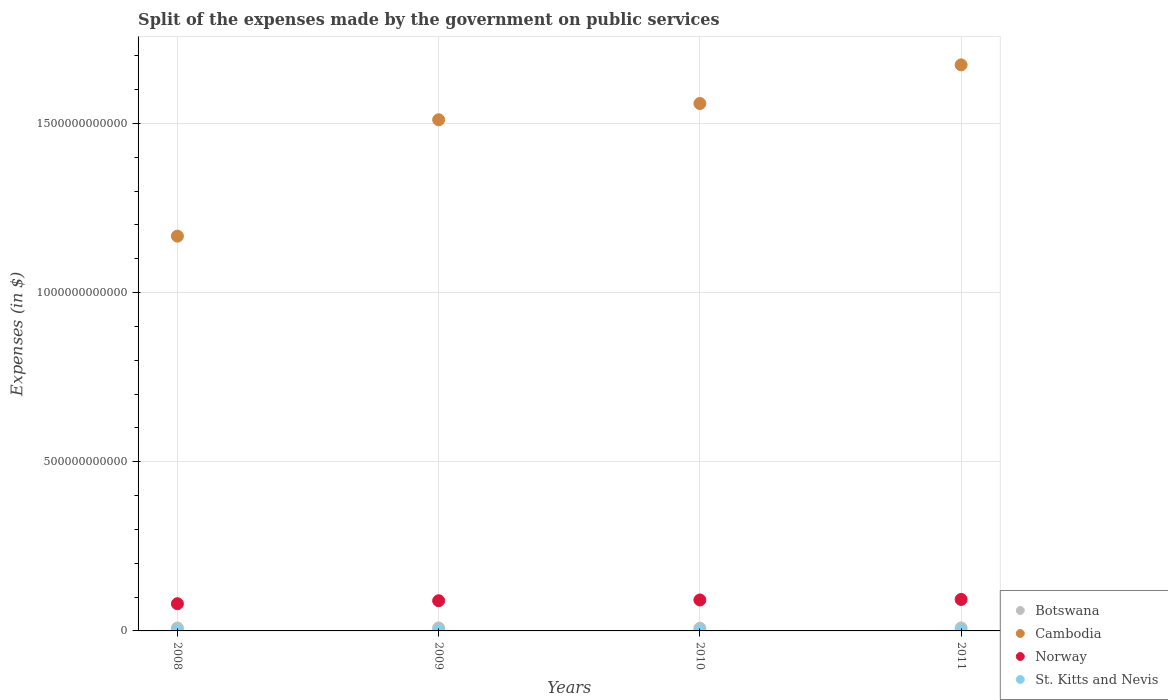How many different coloured dotlines are there?
Give a very brief answer. 4. What is the expenses made by the government on public services in St. Kitts and Nevis in 2009?
Keep it short and to the point. 1.29e+08. Across all years, what is the maximum expenses made by the government on public services in St. Kitts and Nevis?
Keep it short and to the point. 1.76e+08. Across all years, what is the minimum expenses made by the government on public services in Cambodia?
Your answer should be very brief. 1.17e+12. In which year was the expenses made by the government on public services in Botswana minimum?
Your response must be concise. 2010. What is the total expenses made by the government on public services in Cambodia in the graph?
Offer a terse response. 5.91e+12. What is the difference between the expenses made by the government on public services in St. Kitts and Nevis in 2009 and that in 2011?
Offer a very short reply. -4.70e+07. What is the difference between the expenses made by the government on public services in Botswana in 2010 and the expenses made by the government on public services in Cambodia in 2009?
Offer a very short reply. -1.50e+12. What is the average expenses made by the government on public services in Botswana per year?
Keep it short and to the point. 8.56e+09. In the year 2008, what is the difference between the expenses made by the government on public services in Botswana and expenses made by the government on public services in Cambodia?
Your answer should be very brief. -1.16e+12. In how many years, is the expenses made by the government on public services in Botswana greater than 500000000000 $?
Give a very brief answer. 0. What is the ratio of the expenses made by the government on public services in Cambodia in 2010 to that in 2011?
Make the answer very short. 0.93. What is the difference between the highest and the second highest expenses made by the government on public services in Cambodia?
Your response must be concise. 1.14e+11. What is the difference between the highest and the lowest expenses made by the government on public services in Cambodia?
Keep it short and to the point. 5.06e+11. Is the sum of the expenses made by the government on public services in Norway in 2010 and 2011 greater than the maximum expenses made by the government on public services in St. Kitts and Nevis across all years?
Provide a short and direct response. Yes. Is it the case that in every year, the sum of the expenses made by the government on public services in Botswana and expenses made by the government on public services in St. Kitts and Nevis  is greater than the sum of expenses made by the government on public services in Cambodia and expenses made by the government on public services in Norway?
Keep it short and to the point. No. Is it the case that in every year, the sum of the expenses made by the government on public services in Norway and expenses made by the government on public services in St. Kitts and Nevis  is greater than the expenses made by the government on public services in Botswana?
Offer a very short reply. Yes. Is the expenses made by the government on public services in Botswana strictly greater than the expenses made by the government on public services in Norway over the years?
Offer a terse response. No. Is the expenses made by the government on public services in Botswana strictly less than the expenses made by the government on public services in Cambodia over the years?
Keep it short and to the point. Yes. How many dotlines are there?
Offer a very short reply. 4. What is the difference between two consecutive major ticks on the Y-axis?
Offer a terse response. 5.00e+11. How are the legend labels stacked?
Your answer should be very brief. Vertical. What is the title of the graph?
Give a very brief answer. Split of the expenses made by the government on public services. What is the label or title of the X-axis?
Offer a very short reply. Years. What is the label or title of the Y-axis?
Offer a very short reply. Expenses (in $). What is the Expenses (in $) in Botswana in 2008?
Keep it short and to the point. 8.64e+09. What is the Expenses (in $) in Cambodia in 2008?
Ensure brevity in your answer.  1.17e+12. What is the Expenses (in $) in Norway in 2008?
Offer a very short reply. 8.04e+1. What is the Expenses (in $) of St. Kitts and Nevis in 2008?
Your answer should be very brief. 1.37e+08. What is the Expenses (in $) of Botswana in 2009?
Keep it short and to the point. 8.80e+09. What is the Expenses (in $) of Cambodia in 2009?
Your answer should be very brief. 1.51e+12. What is the Expenses (in $) of Norway in 2009?
Make the answer very short. 8.92e+1. What is the Expenses (in $) in St. Kitts and Nevis in 2009?
Your answer should be compact. 1.29e+08. What is the Expenses (in $) in Botswana in 2010?
Your answer should be compact. 7.94e+09. What is the Expenses (in $) of Cambodia in 2010?
Offer a terse response. 1.56e+12. What is the Expenses (in $) in Norway in 2010?
Ensure brevity in your answer.  9.15e+1. What is the Expenses (in $) of St. Kitts and Nevis in 2010?
Offer a terse response. 1.18e+08. What is the Expenses (in $) of Botswana in 2011?
Offer a terse response. 8.84e+09. What is the Expenses (in $) in Cambodia in 2011?
Give a very brief answer. 1.67e+12. What is the Expenses (in $) in Norway in 2011?
Your response must be concise. 9.30e+1. What is the Expenses (in $) in St. Kitts and Nevis in 2011?
Provide a short and direct response. 1.76e+08. Across all years, what is the maximum Expenses (in $) in Botswana?
Provide a short and direct response. 8.84e+09. Across all years, what is the maximum Expenses (in $) of Cambodia?
Make the answer very short. 1.67e+12. Across all years, what is the maximum Expenses (in $) of Norway?
Keep it short and to the point. 9.30e+1. Across all years, what is the maximum Expenses (in $) of St. Kitts and Nevis?
Your response must be concise. 1.76e+08. Across all years, what is the minimum Expenses (in $) of Botswana?
Your answer should be very brief. 7.94e+09. Across all years, what is the minimum Expenses (in $) in Cambodia?
Provide a short and direct response. 1.17e+12. Across all years, what is the minimum Expenses (in $) in Norway?
Your answer should be very brief. 8.04e+1. Across all years, what is the minimum Expenses (in $) of St. Kitts and Nevis?
Give a very brief answer. 1.18e+08. What is the total Expenses (in $) of Botswana in the graph?
Keep it short and to the point. 3.42e+1. What is the total Expenses (in $) of Cambodia in the graph?
Your answer should be compact. 5.91e+12. What is the total Expenses (in $) of Norway in the graph?
Your answer should be compact. 3.54e+11. What is the total Expenses (in $) of St. Kitts and Nevis in the graph?
Keep it short and to the point. 5.60e+08. What is the difference between the Expenses (in $) of Botswana in 2008 and that in 2009?
Provide a short and direct response. -1.62e+08. What is the difference between the Expenses (in $) of Cambodia in 2008 and that in 2009?
Offer a terse response. -3.44e+11. What is the difference between the Expenses (in $) in Norway in 2008 and that in 2009?
Your answer should be very brief. -8.85e+09. What is the difference between the Expenses (in $) of St. Kitts and Nevis in 2008 and that in 2009?
Offer a terse response. 8.10e+06. What is the difference between the Expenses (in $) in Botswana in 2008 and that in 2010?
Your answer should be very brief. 6.99e+08. What is the difference between the Expenses (in $) in Cambodia in 2008 and that in 2010?
Keep it short and to the point. -3.92e+11. What is the difference between the Expenses (in $) of Norway in 2008 and that in 2010?
Offer a very short reply. -1.11e+1. What is the difference between the Expenses (in $) of St. Kitts and Nevis in 2008 and that in 2010?
Your answer should be very brief. 1.91e+07. What is the difference between the Expenses (in $) of Botswana in 2008 and that in 2011?
Give a very brief answer. -2.00e+08. What is the difference between the Expenses (in $) in Cambodia in 2008 and that in 2011?
Make the answer very short. -5.06e+11. What is the difference between the Expenses (in $) in Norway in 2008 and that in 2011?
Offer a terse response. -1.26e+1. What is the difference between the Expenses (in $) in St. Kitts and Nevis in 2008 and that in 2011?
Make the answer very short. -3.89e+07. What is the difference between the Expenses (in $) in Botswana in 2009 and that in 2010?
Make the answer very short. 8.61e+08. What is the difference between the Expenses (in $) of Cambodia in 2009 and that in 2010?
Offer a terse response. -4.80e+1. What is the difference between the Expenses (in $) in Norway in 2009 and that in 2010?
Keep it short and to the point. -2.29e+09. What is the difference between the Expenses (in $) of St. Kitts and Nevis in 2009 and that in 2010?
Offer a very short reply. 1.10e+07. What is the difference between the Expenses (in $) in Botswana in 2009 and that in 2011?
Your response must be concise. -3.82e+07. What is the difference between the Expenses (in $) in Cambodia in 2009 and that in 2011?
Your response must be concise. -1.62e+11. What is the difference between the Expenses (in $) in Norway in 2009 and that in 2011?
Offer a very short reply. -3.76e+09. What is the difference between the Expenses (in $) in St. Kitts and Nevis in 2009 and that in 2011?
Make the answer very short. -4.70e+07. What is the difference between the Expenses (in $) of Botswana in 2010 and that in 2011?
Give a very brief answer. -8.99e+08. What is the difference between the Expenses (in $) in Cambodia in 2010 and that in 2011?
Your answer should be compact. -1.14e+11. What is the difference between the Expenses (in $) of Norway in 2010 and that in 2011?
Offer a terse response. -1.47e+09. What is the difference between the Expenses (in $) of St. Kitts and Nevis in 2010 and that in 2011?
Ensure brevity in your answer.  -5.80e+07. What is the difference between the Expenses (in $) in Botswana in 2008 and the Expenses (in $) in Cambodia in 2009?
Keep it short and to the point. -1.50e+12. What is the difference between the Expenses (in $) of Botswana in 2008 and the Expenses (in $) of Norway in 2009?
Make the answer very short. -8.06e+1. What is the difference between the Expenses (in $) in Botswana in 2008 and the Expenses (in $) in St. Kitts and Nevis in 2009?
Offer a very short reply. 8.51e+09. What is the difference between the Expenses (in $) in Cambodia in 2008 and the Expenses (in $) in Norway in 2009?
Make the answer very short. 1.08e+12. What is the difference between the Expenses (in $) of Cambodia in 2008 and the Expenses (in $) of St. Kitts and Nevis in 2009?
Give a very brief answer. 1.17e+12. What is the difference between the Expenses (in $) in Norway in 2008 and the Expenses (in $) in St. Kitts and Nevis in 2009?
Your response must be concise. 8.03e+1. What is the difference between the Expenses (in $) of Botswana in 2008 and the Expenses (in $) of Cambodia in 2010?
Ensure brevity in your answer.  -1.55e+12. What is the difference between the Expenses (in $) of Botswana in 2008 and the Expenses (in $) of Norway in 2010?
Ensure brevity in your answer.  -8.29e+1. What is the difference between the Expenses (in $) in Botswana in 2008 and the Expenses (in $) in St. Kitts and Nevis in 2010?
Provide a succinct answer. 8.52e+09. What is the difference between the Expenses (in $) of Cambodia in 2008 and the Expenses (in $) of Norway in 2010?
Offer a terse response. 1.08e+12. What is the difference between the Expenses (in $) in Cambodia in 2008 and the Expenses (in $) in St. Kitts and Nevis in 2010?
Provide a short and direct response. 1.17e+12. What is the difference between the Expenses (in $) in Norway in 2008 and the Expenses (in $) in St. Kitts and Nevis in 2010?
Your answer should be compact. 8.03e+1. What is the difference between the Expenses (in $) in Botswana in 2008 and the Expenses (in $) in Cambodia in 2011?
Provide a short and direct response. -1.66e+12. What is the difference between the Expenses (in $) of Botswana in 2008 and the Expenses (in $) of Norway in 2011?
Provide a short and direct response. -8.44e+1. What is the difference between the Expenses (in $) in Botswana in 2008 and the Expenses (in $) in St. Kitts and Nevis in 2011?
Give a very brief answer. 8.46e+09. What is the difference between the Expenses (in $) of Cambodia in 2008 and the Expenses (in $) of Norway in 2011?
Offer a very short reply. 1.07e+12. What is the difference between the Expenses (in $) of Cambodia in 2008 and the Expenses (in $) of St. Kitts and Nevis in 2011?
Make the answer very short. 1.17e+12. What is the difference between the Expenses (in $) of Norway in 2008 and the Expenses (in $) of St. Kitts and Nevis in 2011?
Keep it short and to the point. 8.02e+1. What is the difference between the Expenses (in $) in Botswana in 2009 and the Expenses (in $) in Cambodia in 2010?
Your answer should be compact. -1.55e+12. What is the difference between the Expenses (in $) in Botswana in 2009 and the Expenses (in $) in Norway in 2010?
Make the answer very short. -8.27e+1. What is the difference between the Expenses (in $) of Botswana in 2009 and the Expenses (in $) of St. Kitts and Nevis in 2010?
Your response must be concise. 8.68e+09. What is the difference between the Expenses (in $) in Cambodia in 2009 and the Expenses (in $) in Norway in 2010?
Provide a succinct answer. 1.42e+12. What is the difference between the Expenses (in $) of Cambodia in 2009 and the Expenses (in $) of St. Kitts and Nevis in 2010?
Offer a very short reply. 1.51e+12. What is the difference between the Expenses (in $) of Norway in 2009 and the Expenses (in $) of St. Kitts and Nevis in 2010?
Offer a terse response. 8.91e+1. What is the difference between the Expenses (in $) of Botswana in 2009 and the Expenses (in $) of Cambodia in 2011?
Offer a terse response. -1.66e+12. What is the difference between the Expenses (in $) in Botswana in 2009 and the Expenses (in $) in Norway in 2011?
Make the answer very short. -8.42e+1. What is the difference between the Expenses (in $) of Botswana in 2009 and the Expenses (in $) of St. Kitts and Nevis in 2011?
Your answer should be compact. 8.63e+09. What is the difference between the Expenses (in $) in Cambodia in 2009 and the Expenses (in $) in Norway in 2011?
Make the answer very short. 1.42e+12. What is the difference between the Expenses (in $) in Cambodia in 2009 and the Expenses (in $) in St. Kitts and Nevis in 2011?
Make the answer very short. 1.51e+12. What is the difference between the Expenses (in $) in Norway in 2009 and the Expenses (in $) in St. Kitts and Nevis in 2011?
Ensure brevity in your answer.  8.91e+1. What is the difference between the Expenses (in $) of Botswana in 2010 and the Expenses (in $) of Cambodia in 2011?
Offer a very short reply. -1.67e+12. What is the difference between the Expenses (in $) in Botswana in 2010 and the Expenses (in $) in Norway in 2011?
Your answer should be very brief. -8.50e+1. What is the difference between the Expenses (in $) of Botswana in 2010 and the Expenses (in $) of St. Kitts and Nevis in 2011?
Give a very brief answer. 7.76e+09. What is the difference between the Expenses (in $) in Cambodia in 2010 and the Expenses (in $) in Norway in 2011?
Keep it short and to the point. 1.47e+12. What is the difference between the Expenses (in $) of Cambodia in 2010 and the Expenses (in $) of St. Kitts and Nevis in 2011?
Offer a terse response. 1.56e+12. What is the difference between the Expenses (in $) in Norway in 2010 and the Expenses (in $) in St. Kitts and Nevis in 2011?
Provide a succinct answer. 9.13e+1. What is the average Expenses (in $) of Botswana per year?
Provide a succinct answer. 8.56e+09. What is the average Expenses (in $) in Cambodia per year?
Provide a short and direct response. 1.48e+12. What is the average Expenses (in $) in Norway per year?
Make the answer very short. 8.85e+1. What is the average Expenses (in $) in St. Kitts and Nevis per year?
Your response must be concise. 1.40e+08. In the year 2008, what is the difference between the Expenses (in $) of Botswana and Expenses (in $) of Cambodia?
Your response must be concise. -1.16e+12. In the year 2008, what is the difference between the Expenses (in $) in Botswana and Expenses (in $) in Norway?
Your answer should be compact. -7.17e+1. In the year 2008, what is the difference between the Expenses (in $) in Botswana and Expenses (in $) in St. Kitts and Nevis?
Give a very brief answer. 8.50e+09. In the year 2008, what is the difference between the Expenses (in $) in Cambodia and Expenses (in $) in Norway?
Your answer should be compact. 1.09e+12. In the year 2008, what is the difference between the Expenses (in $) in Cambodia and Expenses (in $) in St. Kitts and Nevis?
Provide a succinct answer. 1.17e+12. In the year 2008, what is the difference between the Expenses (in $) of Norway and Expenses (in $) of St. Kitts and Nevis?
Make the answer very short. 8.02e+1. In the year 2009, what is the difference between the Expenses (in $) in Botswana and Expenses (in $) in Cambodia?
Your answer should be compact. -1.50e+12. In the year 2009, what is the difference between the Expenses (in $) of Botswana and Expenses (in $) of Norway?
Ensure brevity in your answer.  -8.04e+1. In the year 2009, what is the difference between the Expenses (in $) of Botswana and Expenses (in $) of St. Kitts and Nevis?
Offer a very short reply. 8.67e+09. In the year 2009, what is the difference between the Expenses (in $) in Cambodia and Expenses (in $) in Norway?
Your response must be concise. 1.42e+12. In the year 2009, what is the difference between the Expenses (in $) of Cambodia and Expenses (in $) of St. Kitts and Nevis?
Your answer should be very brief. 1.51e+12. In the year 2009, what is the difference between the Expenses (in $) in Norway and Expenses (in $) in St. Kitts and Nevis?
Your answer should be compact. 8.91e+1. In the year 2010, what is the difference between the Expenses (in $) of Botswana and Expenses (in $) of Cambodia?
Offer a terse response. -1.55e+12. In the year 2010, what is the difference between the Expenses (in $) of Botswana and Expenses (in $) of Norway?
Ensure brevity in your answer.  -8.36e+1. In the year 2010, what is the difference between the Expenses (in $) of Botswana and Expenses (in $) of St. Kitts and Nevis?
Ensure brevity in your answer.  7.82e+09. In the year 2010, what is the difference between the Expenses (in $) in Cambodia and Expenses (in $) in Norway?
Your answer should be compact. 1.47e+12. In the year 2010, what is the difference between the Expenses (in $) of Cambodia and Expenses (in $) of St. Kitts and Nevis?
Offer a terse response. 1.56e+12. In the year 2010, what is the difference between the Expenses (in $) in Norway and Expenses (in $) in St. Kitts and Nevis?
Make the answer very short. 9.14e+1. In the year 2011, what is the difference between the Expenses (in $) in Botswana and Expenses (in $) in Cambodia?
Your answer should be very brief. -1.66e+12. In the year 2011, what is the difference between the Expenses (in $) of Botswana and Expenses (in $) of Norway?
Your response must be concise. -8.41e+1. In the year 2011, what is the difference between the Expenses (in $) in Botswana and Expenses (in $) in St. Kitts and Nevis?
Your answer should be very brief. 8.66e+09. In the year 2011, what is the difference between the Expenses (in $) in Cambodia and Expenses (in $) in Norway?
Offer a terse response. 1.58e+12. In the year 2011, what is the difference between the Expenses (in $) in Cambodia and Expenses (in $) in St. Kitts and Nevis?
Give a very brief answer. 1.67e+12. In the year 2011, what is the difference between the Expenses (in $) of Norway and Expenses (in $) of St. Kitts and Nevis?
Offer a terse response. 9.28e+1. What is the ratio of the Expenses (in $) of Botswana in 2008 to that in 2009?
Ensure brevity in your answer.  0.98. What is the ratio of the Expenses (in $) of Cambodia in 2008 to that in 2009?
Give a very brief answer. 0.77. What is the ratio of the Expenses (in $) of Norway in 2008 to that in 2009?
Your answer should be very brief. 0.9. What is the ratio of the Expenses (in $) in St. Kitts and Nevis in 2008 to that in 2009?
Your answer should be compact. 1.06. What is the ratio of the Expenses (in $) in Botswana in 2008 to that in 2010?
Give a very brief answer. 1.09. What is the ratio of the Expenses (in $) of Cambodia in 2008 to that in 2010?
Offer a terse response. 0.75. What is the ratio of the Expenses (in $) of Norway in 2008 to that in 2010?
Your response must be concise. 0.88. What is the ratio of the Expenses (in $) of St. Kitts and Nevis in 2008 to that in 2010?
Your answer should be very brief. 1.16. What is the ratio of the Expenses (in $) of Botswana in 2008 to that in 2011?
Your answer should be compact. 0.98. What is the ratio of the Expenses (in $) in Cambodia in 2008 to that in 2011?
Your answer should be compact. 0.7. What is the ratio of the Expenses (in $) in Norway in 2008 to that in 2011?
Your answer should be compact. 0.86. What is the ratio of the Expenses (in $) in St. Kitts and Nevis in 2008 to that in 2011?
Provide a succinct answer. 0.78. What is the ratio of the Expenses (in $) of Botswana in 2009 to that in 2010?
Offer a very short reply. 1.11. What is the ratio of the Expenses (in $) in Cambodia in 2009 to that in 2010?
Give a very brief answer. 0.97. What is the ratio of the Expenses (in $) of St. Kitts and Nevis in 2009 to that in 2010?
Keep it short and to the point. 1.09. What is the ratio of the Expenses (in $) of Cambodia in 2009 to that in 2011?
Provide a short and direct response. 0.9. What is the ratio of the Expenses (in $) in Norway in 2009 to that in 2011?
Provide a succinct answer. 0.96. What is the ratio of the Expenses (in $) of St. Kitts and Nevis in 2009 to that in 2011?
Your answer should be very brief. 0.73. What is the ratio of the Expenses (in $) in Botswana in 2010 to that in 2011?
Your response must be concise. 0.9. What is the ratio of the Expenses (in $) in Cambodia in 2010 to that in 2011?
Give a very brief answer. 0.93. What is the ratio of the Expenses (in $) of Norway in 2010 to that in 2011?
Your answer should be compact. 0.98. What is the ratio of the Expenses (in $) of St. Kitts and Nevis in 2010 to that in 2011?
Provide a short and direct response. 0.67. What is the difference between the highest and the second highest Expenses (in $) in Botswana?
Your answer should be compact. 3.82e+07. What is the difference between the highest and the second highest Expenses (in $) of Cambodia?
Make the answer very short. 1.14e+11. What is the difference between the highest and the second highest Expenses (in $) in Norway?
Your answer should be compact. 1.47e+09. What is the difference between the highest and the second highest Expenses (in $) in St. Kitts and Nevis?
Ensure brevity in your answer.  3.89e+07. What is the difference between the highest and the lowest Expenses (in $) of Botswana?
Provide a short and direct response. 8.99e+08. What is the difference between the highest and the lowest Expenses (in $) in Cambodia?
Offer a very short reply. 5.06e+11. What is the difference between the highest and the lowest Expenses (in $) of Norway?
Offer a very short reply. 1.26e+1. What is the difference between the highest and the lowest Expenses (in $) in St. Kitts and Nevis?
Ensure brevity in your answer.  5.80e+07. 